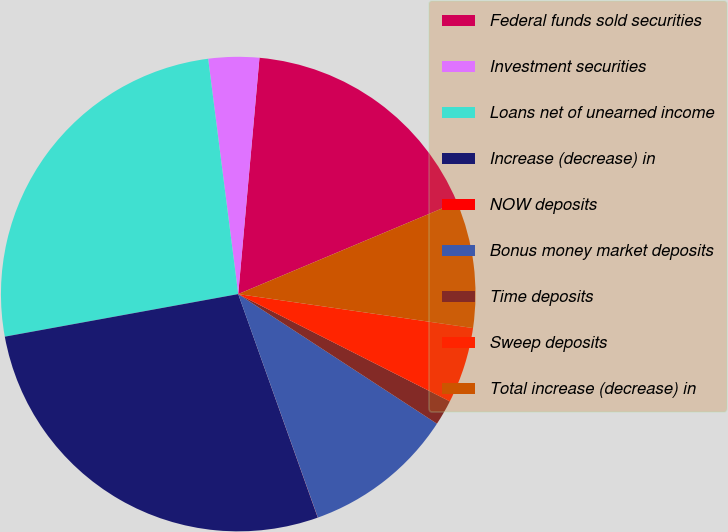Convert chart to OTSL. <chart><loc_0><loc_0><loc_500><loc_500><pie_chart><fcel>Federal funds sold securities<fcel>Investment securities<fcel>Loans net of unearned income<fcel>Increase (decrease) in<fcel>NOW deposits<fcel>Bonus money market deposits<fcel>Time deposits<fcel>Sweep deposits<fcel>Total increase (decrease) in<nl><fcel>17.24%<fcel>3.45%<fcel>25.85%<fcel>27.57%<fcel>0.01%<fcel>10.35%<fcel>1.73%<fcel>5.18%<fcel>8.62%<nl></chart> 